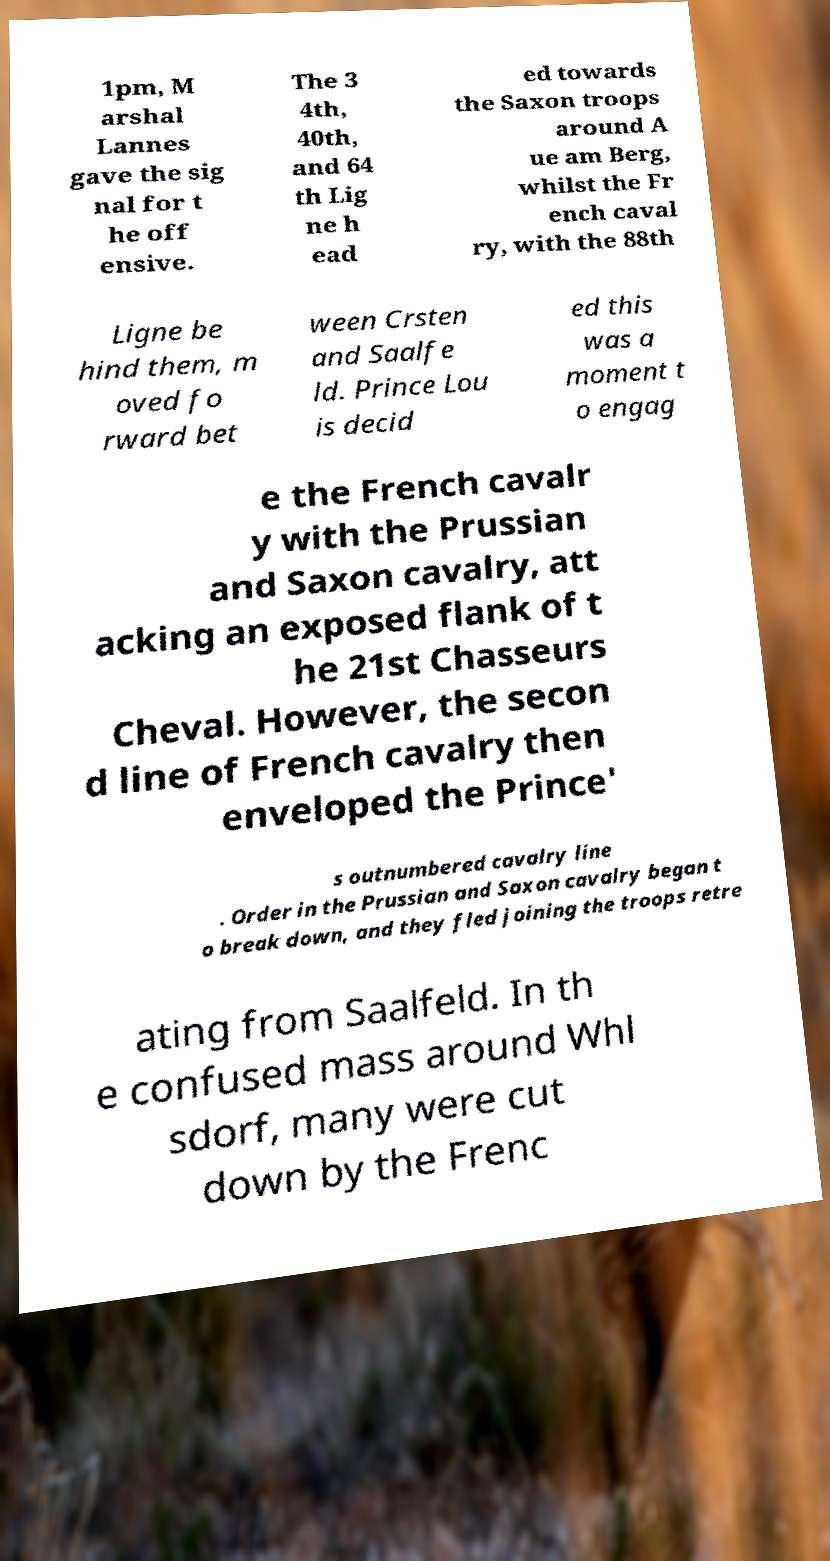Please read and relay the text visible in this image. What does it say? 1pm, M arshal Lannes gave the sig nal for t he off ensive. The 3 4th, 40th, and 64 th Lig ne h ead ed towards the Saxon troops around A ue am Berg, whilst the Fr ench caval ry, with the 88th Ligne be hind them, m oved fo rward bet ween Crsten and Saalfe ld. Prince Lou is decid ed this was a moment t o engag e the French cavalr y with the Prussian and Saxon cavalry, att acking an exposed flank of t he 21st Chasseurs Cheval. However, the secon d line of French cavalry then enveloped the Prince' s outnumbered cavalry line . Order in the Prussian and Saxon cavalry began t o break down, and they fled joining the troops retre ating from Saalfeld. In th e confused mass around Whl sdorf, many were cut down by the Frenc 